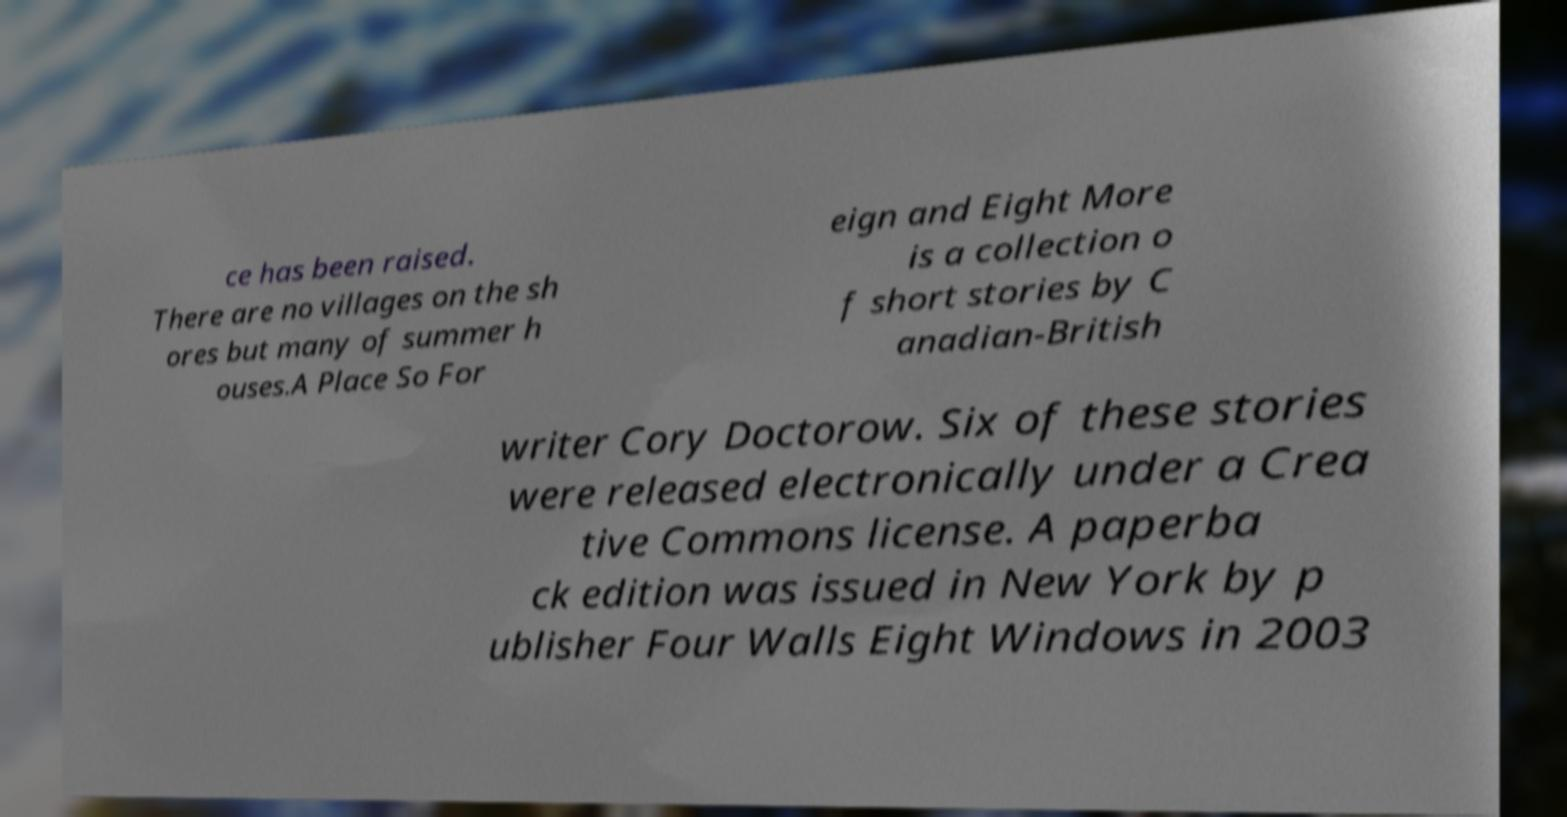I need the written content from this picture converted into text. Can you do that? ce has been raised. There are no villages on the sh ores but many of summer h ouses.A Place So For eign and Eight More is a collection o f short stories by C anadian-British writer Cory Doctorow. Six of these stories were released electronically under a Crea tive Commons license. A paperba ck edition was issued in New York by p ublisher Four Walls Eight Windows in 2003 